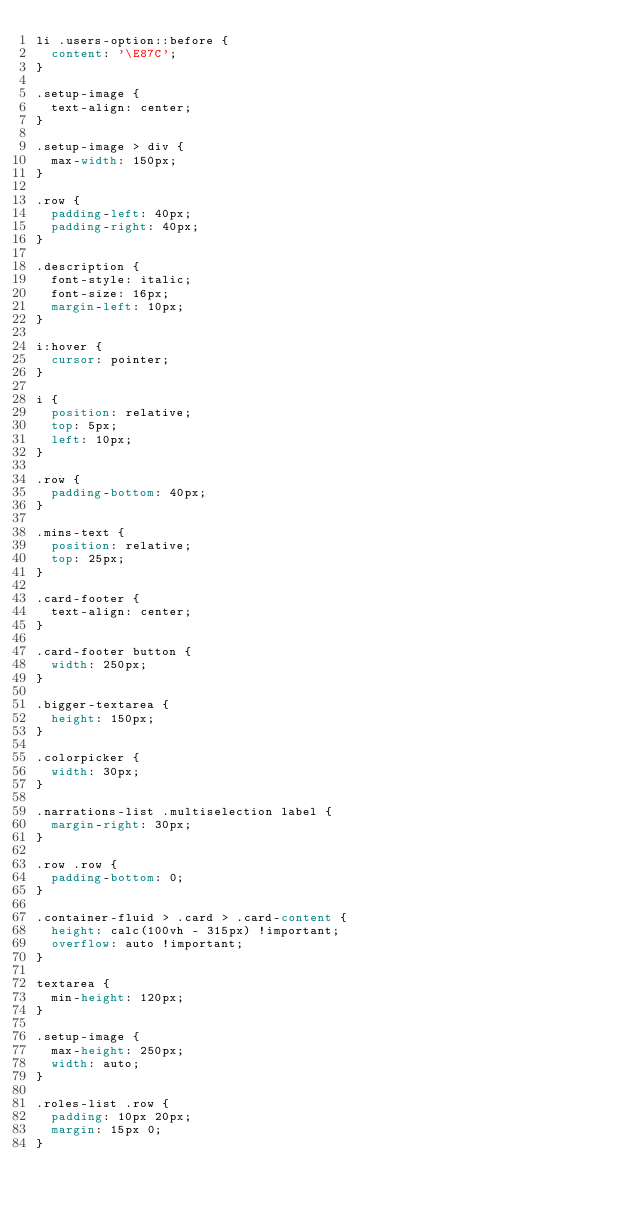<code> <loc_0><loc_0><loc_500><loc_500><_CSS_>li .users-option::before {
  content: '\E87C';
}

.setup-image {
  text-align: center;
}

.setup-image > div {
  max-width: 150px;
}

.row {
  padding-left: 40px;
  padding-right: 40px;
}

.description {
  font-style: italic;
  font-size: 16px;
  margin-left: 10px;
}

i:hover {
  cursor: pointer;
}

i {
  position: relative;
  top: 5px;
  left: 10px;
}

.row {
  padding-bottom: 40px;
}

.mins-text {
  position: relative;
  top: 25px;
}

.card-footer {
  text-align: center;
}

.card-footer button {
  width: 250px;
}

.bigger-textarea {
  height: 150px;
}

.colorpicker {
  width: 30px;
}

.narrations-list .multiselection label {
  margin-right: 30px;
}

.row .row {
  padding-bottom: 0;
}

.container-fluid > .card > .card-content {
  height: calc(100vh - 315px) !important;
  overflow: auto !important;
}

textarea {
  min-height: 120px;
}

.setup-image {
  max-height: 250px;
  width: auto;
}

.roles-list .row {
  padding: 10px 20px;
  margin: 15px 0;
}
</code> 